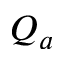Convert formula to latex. <formula><loc_0><loc_0><loc_500><loc_500>Q _ { a }</formula> 